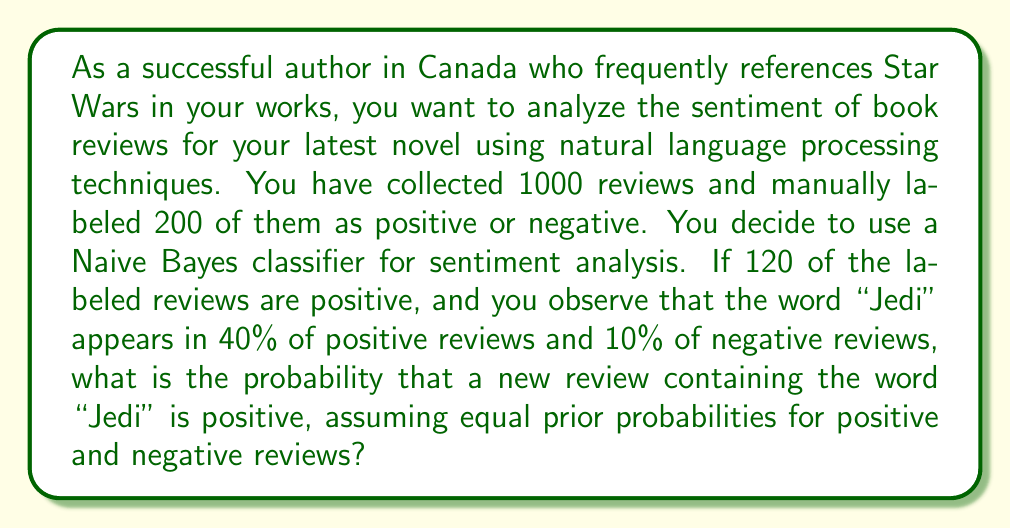Can you solve this math problem? Let's approach this step-by-step using Bayes' theorem:

1) Define our events:
   P = Review is positive
   J = Review contains "Jedi"

2) We're looking for P(P|J), the probability that a review is positive given that it contains "Jedi".

3) Bayes' theorem states:

   $$P(P|J) = \frac{P(J|P) \cdot P(P)}{P(J)}$$

4) We know:
   P(J|P) = 0.40 (40% of positive reviews contain "Jedi")
   P(P) = 0.5 (equal prior probabilities)

5) We need to calculate P(J) using the law of total probability:

   $$P(J) = P(J|P) \cdot P(P) + P(J|N) \cdot P(N)$$

   Where N = Review is negative

6) We know:
   P(J|N) = 0.10 (10% of negative reviews contain "Jedi")
   P(N) = 1 - P(P) = 0.5

7) Calculate P(J):

   $$P(J) = 0.40 \cdot 0.5 + 0.10 \cdot 0.5 = 0.20 + 0.05 = 0.25$$

8) Now we can apply Bayes' theorem:

   $$P(P|J) = \frac{0.40 \cdot 0.5}{0.25} = \frac{0.20}{0.25} = 0.80$$

Thus, the probability that a new review containing "Jedi" is positive is 0.80 or 80%.
Answer: 0.80 or 80% 